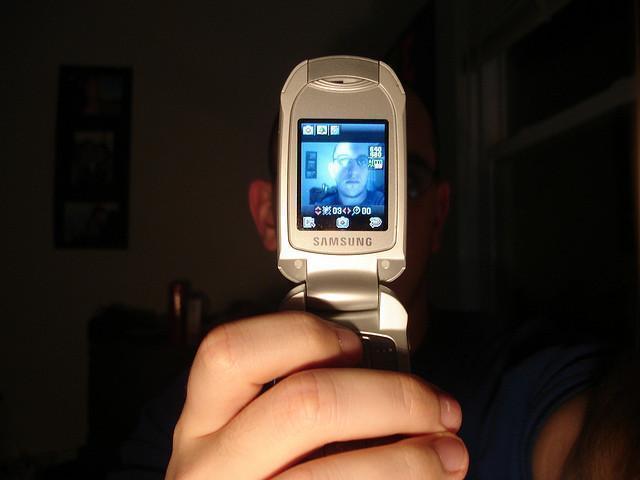What company makes the phone?
Pick the correct solution from the four options below to address the question.
Options: Apple, nokia, ibm, samsung. Samsung. 